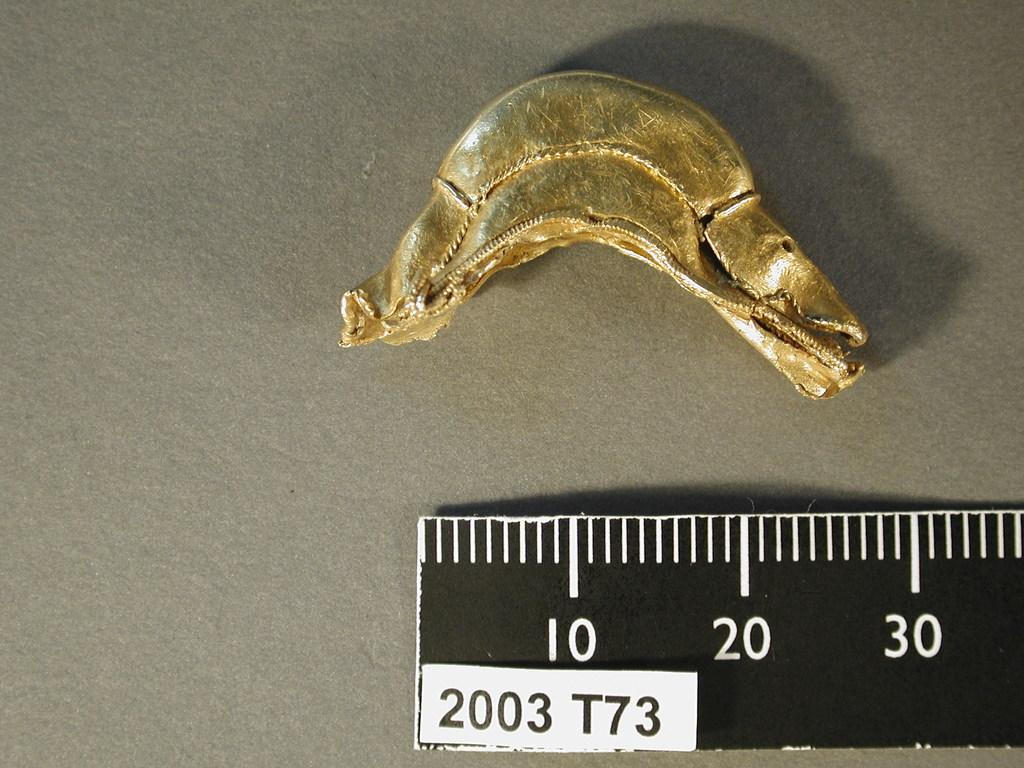<image>
Offer a succinct explanation of the picture presented. A mettalic object being measured by a black and white ruler with a white tag that reads 2003 t73 on the ruler. 